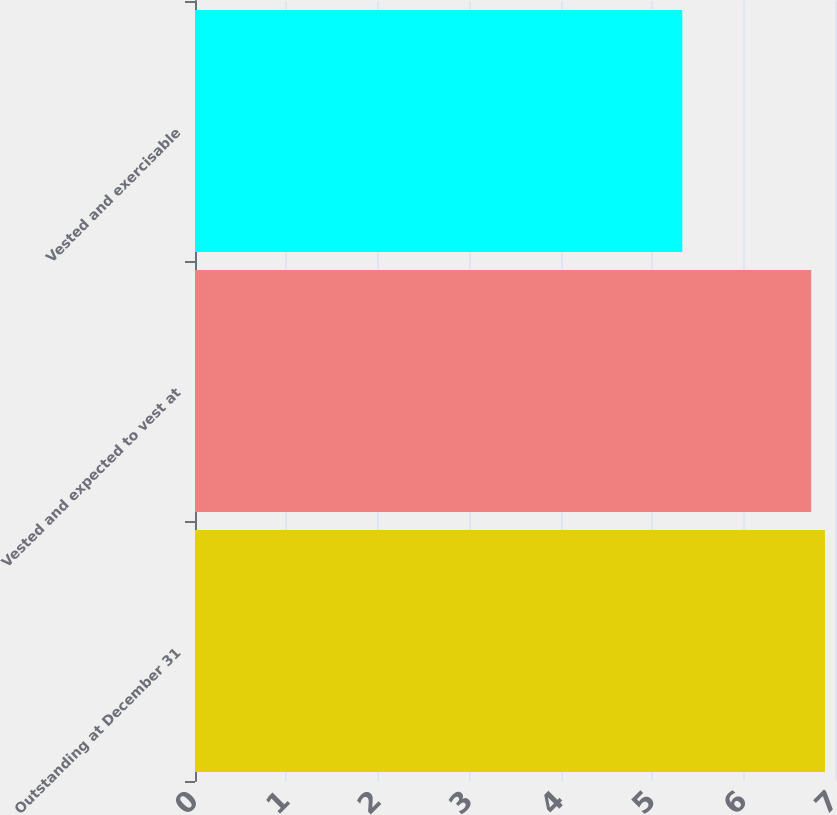<chart> <loc_0><loc_0><loc_500><loc_500><bar_chart><fcel>Outstanding at December 31<fcel>Vested and expected to vest at<fcel>Vested and exercisable<nl><fcel>6.89<fcel>6.74<fcel>5.33<nl></chart> 